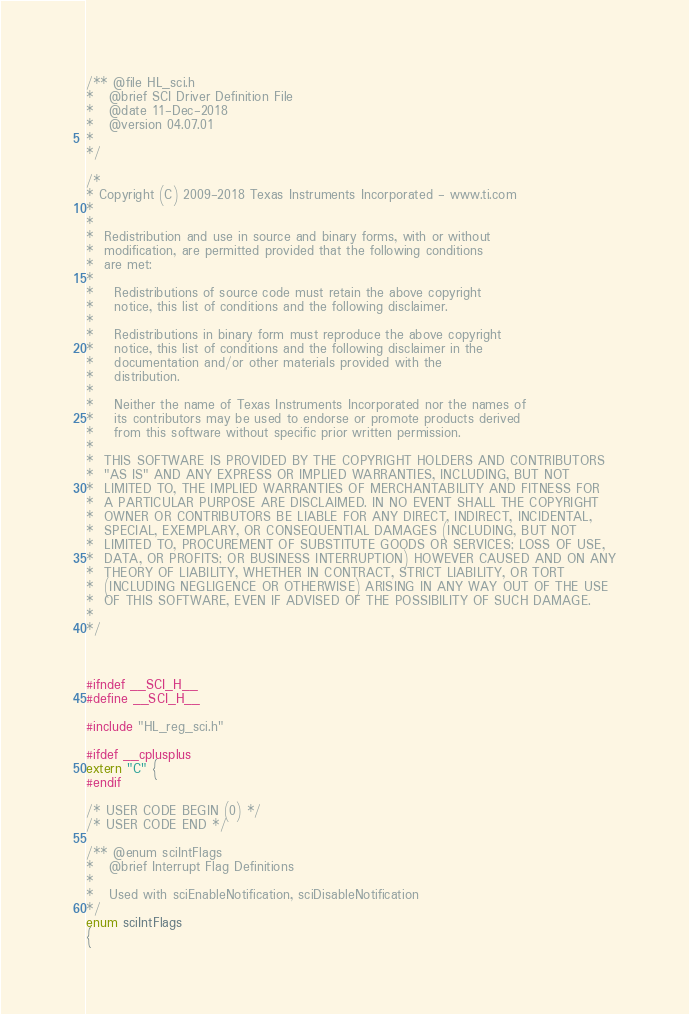<code> <loc_0><loc_0><loc_500><loc_500><_C_>/** @file HL_sci.h
*   @brief SCI Driver Definition File
*   @date 11-Dec-2018
*   @version 04.07.01
*   
*/

/* 
* Copyright (C) 2009-2018 Texas Instruments Incorporated - www.ti.com  
* 
* 
*  Redistribution and use in source and binary forms, with or without 
*  modification, are permitted provided that the following conditions 
*  are met:
*
*    Redistributions of source code must retain the above copyright 
*    notice, this list of conditions and the following disclaimer.
*
*    Redistributions in binary form must reproduce the above copyright
*    notice, this list of conditions and the following disclaimer in the 
*    documentation and/or other materials provided with the   
*    distribution.
*
*    Neither the name of Texas Instruments Incorporated nor the names of
*    its contributors may be used to endorse or promote products derived
*    from this software without specific prior written permission.
*
*  THIS SOFTWARE IS PROVIDED BY THE COPYRIGHT HOLDERS AND CONTRIBUTORS 
*  "AS IS" AND ANY EXPRESS OR IMPLIED WARRANTIES, INCLUDING, BUT NOT 
*  LIMITED TO, THE IMPLIED WARRANTIES OF MERCHANTABILITY AND FITNESS FOR
*  A PARTICULAR PURPOSE ARE DISCLAIMED. IN NO EVENT SHALL THE COPYRIGHT 
*  OWNER OR CONTRIBUTORS BE LIABLE FOR ANY DIRECT, INDIRECT, INCIDENTAL, 
*  SPECIAL, EXEMPLARY, OR CONSEQUENTIAL DAMAGES (INCLUDING, BUT NOT 
*  LIMITED TO, PROCUREMENT OF SUBSTITUTE GOODS OR SERVICES; LOSS OF USE,
*  DATA, OR PROFITS; OR BUSINESS INTERRUPTION) HOWEVER CAUSED AND ON ANY
*  THEORY OF LIABILITY, WHETHER IN CONTRACT, STRICT LIABILITY, OR TORT 
*  (INCLUDING NEGLIGENCE OR OTHERWISE) ARISING IN ANY WAY OUT OF THE USE 
*  OF THIS SOFTWARE, EVEN IF ADVISED OF THE POSSIBILITY OF SUCH DAMAGE.
*
*/



#ifndef __SCI_H__
#define __SCI_H__

#include "HL_reg_sci.h"

#ifdef __cplusplus
extern "C" {
#endif

/* USER CODE BEGIN (0) */
/* USER CODE END */

/** @enum sciIntFlags
*   @brief Interrupt Flag Definitions
*
*   Used with sciEnableNotification, sciDisableNotification
*/
enum sciIntFlags
{</code> 